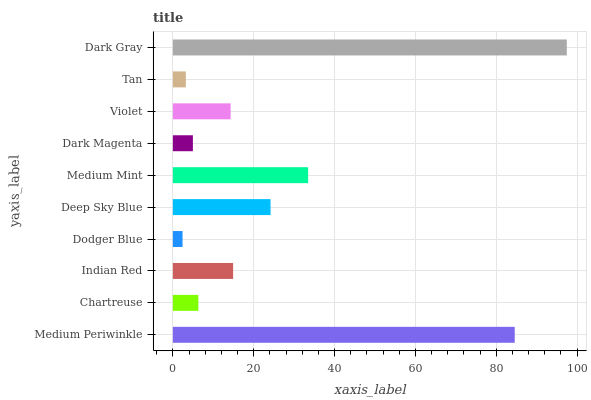Is Dodger Blue the minimum?
Answer yes or no. Yes. Is Dark Gray the maximum?
Answer yes or no. Yes. Is Chartreuse the minimum?
Answer yes or no. No. Is Chartreuse the maximum?
Answer yes or no. No. Is Medium Periwinkle greater than Chartreuse?
Answer yes or no. Yes. Is Chartreuse less than Medium Periwinkle?
Answer yes or no. Yes. Is Chartreuse greater than Medium Periwinkle?
Answer yes or no. No. Is Medium Periwinkle less than Chartreuse?
Answer yes or no. No. Is Indian Red the high median?
Answer yes or no. Yes. Is Violet the low median?
Answer yes or no. Yes. Is Violet the high median?
Answer yes or no. No. Is Indian Red the low median?
Answer yes or no. No. 